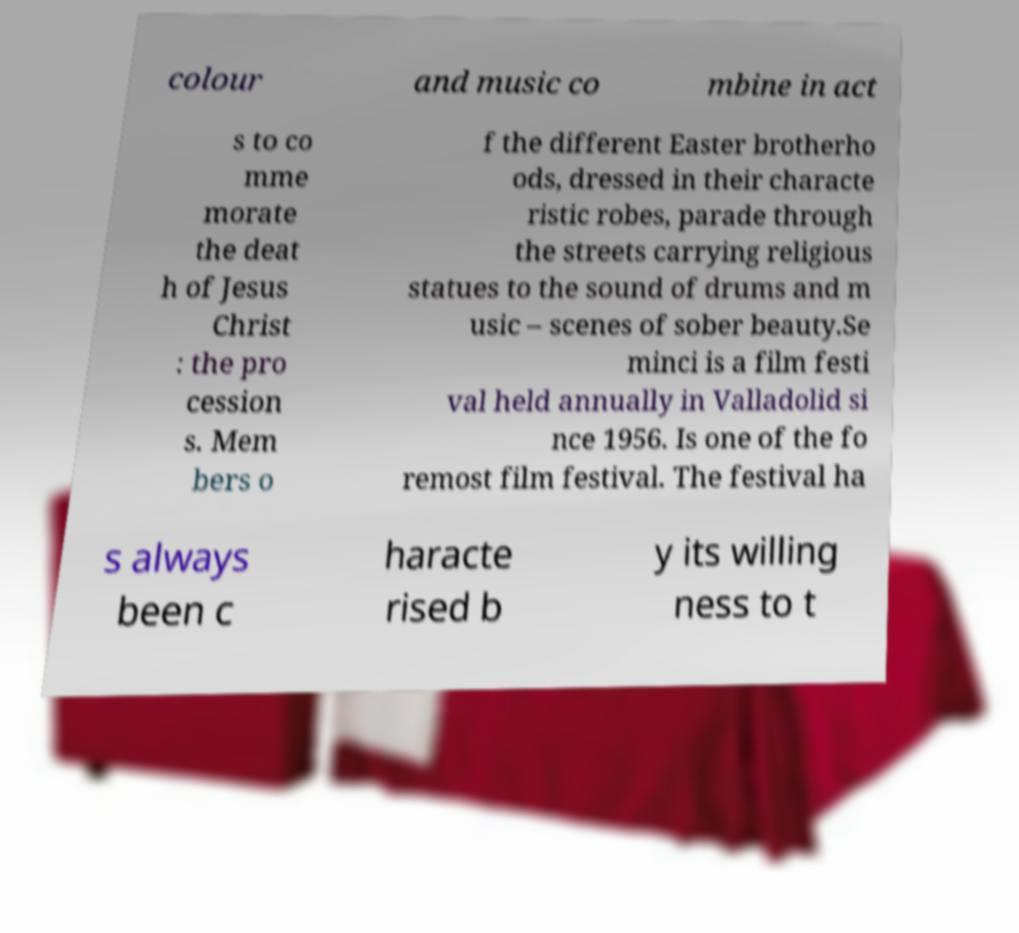I need the written content from this picture converted into text. Can you do that? colour and music co mbine in act s to co mme morate the deat h of Jesus Christ : the pro cession s. Mem bers o f the different Easter brotherho ods, dressed in their characte ristic robes, parade through the streets carrying religious statues to the sound of drums and m usic – scenes of sober beauty.Se minci is a film festi val held annually in Valladolid si nce 1956. Is one of the fo remost film festival. The festival ha s always been c haracte rised b y its willing ness to t 